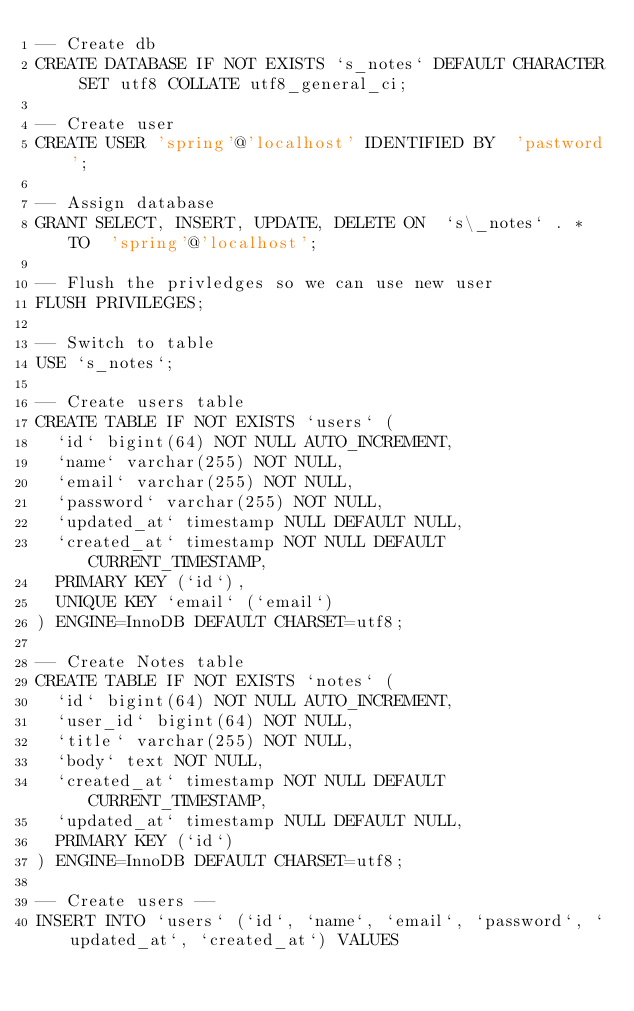<code> <loc_0><loc_0><loc_500><loc_500><_SQL_>-- Create db
CREATE DATABASE IF NOT EXISTS `s_notes` DEFAULT CHARACTER SET utf8 COLLATE utf8_general_ci;

-- Create user
CREATE USER 'spring'@'localhost' IDENTIFIED BY  'pastword';

-- Assign database
GRANT SELECT, INSERT, UPDATE, DELETE ON  `s\_notes` . * TO  'spring'@'localhost';

-- Flush the privledges so we can use new user
FLUSH PRIVILEGES;

-- Switch to table
USE `s_notes`;

-- Create users table
CREATE TABLE IF NOT EXISTS `users` (
  `id` bigint(64) NOT NULL AUTO_INCREMENT,
  `name` varchar(255) NOT NULL,
  `email` varchar(255) NOT NULL,
  `password` varchar(255) NOT NULL,
  `updated_at` timestamp NULL DEFAULT NULL,
  `created_at` timestamp NOT NULL DEFAULT CURRENT_TIMESTAMP,
  PRIMARY KEY (`id`),
  UNIQUE KEY `email` (`email`)
) ENGINE=InnoDB DEFAULT CHARSET=utf8;

-- Create Notes table
CREATE TABLE IF NOT EXISTS `notes` (
  `id` bigint(64) NOT NULL AUTO_INCREMENT,
  `user_id` bigint(64) NOT NULL,
  `title` varchar(255) NOT NULL,
  `body` text NOT NULL,
  `created_at` timestamp NOT NULL DEFAULT CURRENT_TIMESTAMP,
  `updated_at` timestamp NULL DEFAULT NULL,
  PRIMARY KEY (`id`)
) ENGINE=InnoDB DEFAULT CHARSET=utf8;

-- Create users --
INSERT INTO `users` (`id`, `name`, `email`, `password`, `updated_at`, `created_at`) VALUES</code> 